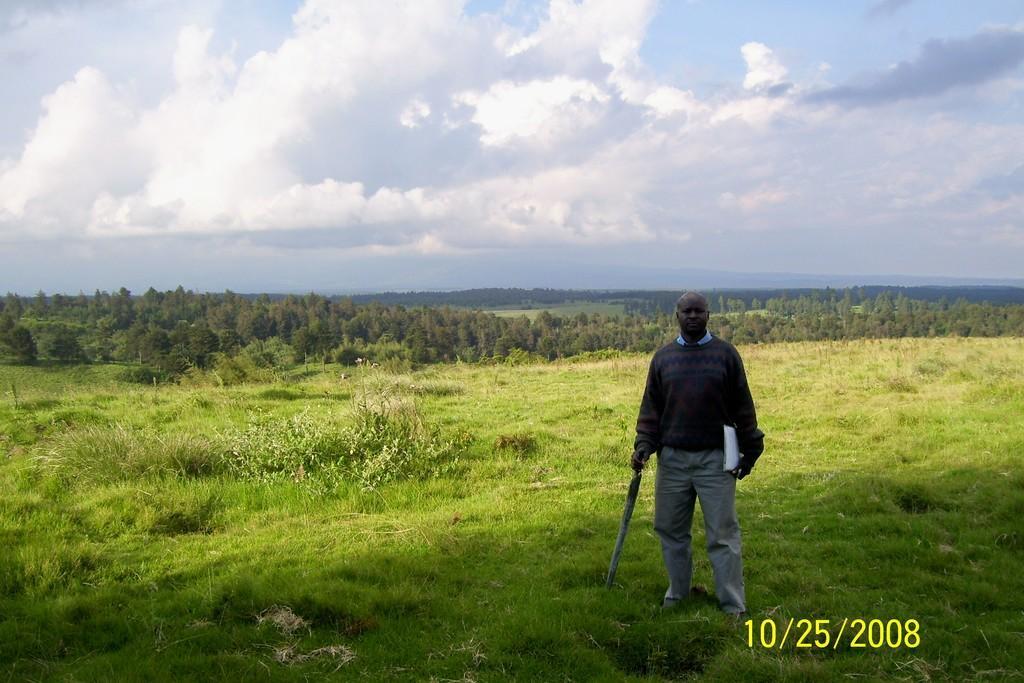Describe this image in one or two sentences. In this image, we can see a person is standing on the grass and holding some objects. Here we can see trees, plants and grass. Background there is a cloudy sky. Right side bottom, we can see a watermark. It represents date. 